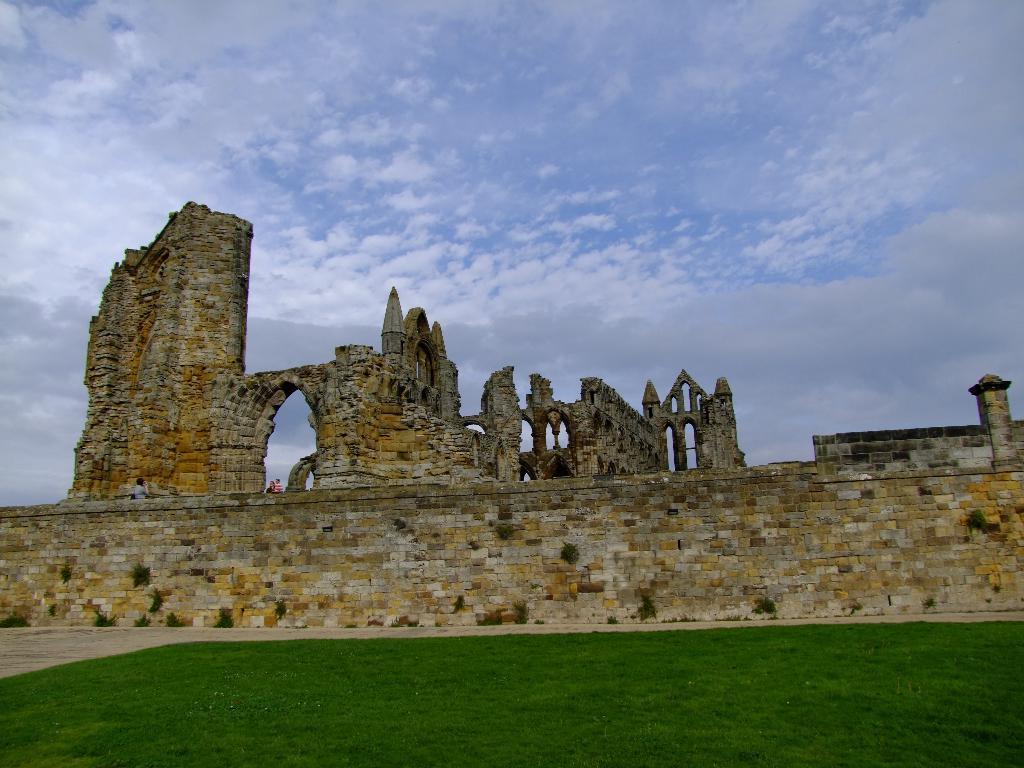Describe this image in one or two sentences. In this image I can see a fort. On the left side, I can see two persons are sitting on the wall. At the bottom of the image I can see the grass in green color. On the top of the image I can see the sky and clouds. 